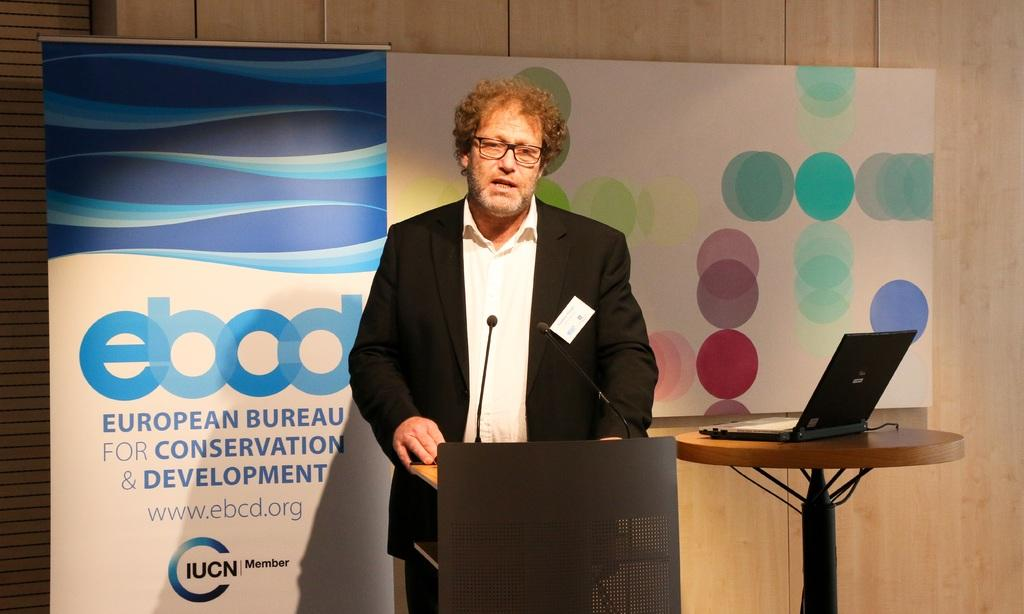What is the man in the image doing? The man is talking on the microphone. What object is present on the stage in the image? There is a podium in the image. What piece of furniture can be seen in the image? There is a table in the image. What electronic device is visible in the image? There is a laptop in the image. What type of decoration is present in the image? There are banners in the image. What is visible in the background of the image? There is a wall in the background of the image. What type of gold car can be seen driving through the wall in the image? There is no car, gold or otherwise, present in the image. The wall in the background is not being driven through by any vehicle. 